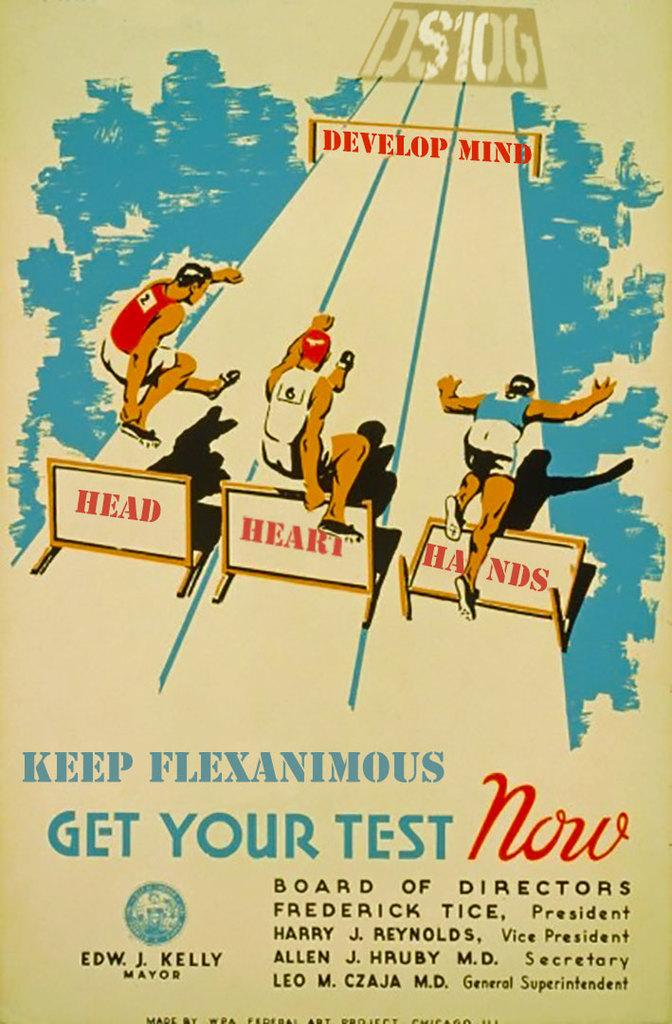<image>
Render a clear and concise summary of the photo. Poster board of get your test now for your health 